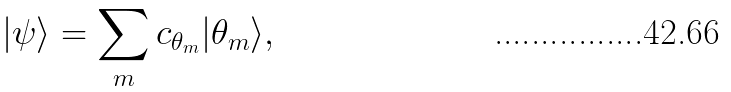<formula> <loc_0><loc_0><loc_500><loc_500>| \psi \rangle = \sum _ { m } c _ { \theta _ { m } } | \theta _ { m } \rangle ,</formula> 